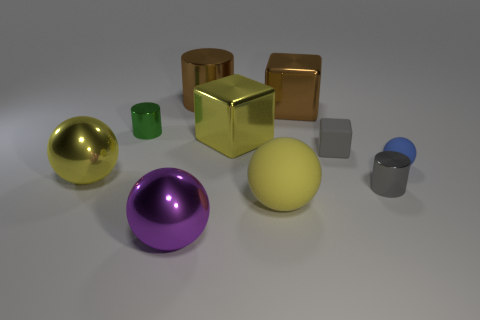There is a object that is behind the tiny matte ball and on the left side of the large purple object; what is its material?
Offer a very short reply. Metal. Is the color of the tiny rubber ball the same as the cylinder on the right side of the small gray rubber block?
Keep it short and to the point. No. There is a purple thing that is the same size as the brown metallic cube; what material is it?
Your answer should be very brief. Metal. Is there a large brown sphere that has the same material as the small gray cube?
Offer a very short reply. No. What number of large purple metal spheres are there?
Provide a short and direct response. 1. Do the big cylinder and the yellow sphere that is in front of the yellow metal ball have the same material?
Offer a very short reply. No. What material is the cylinder that is the same color as the tiny rubber block?
Provide a short and direct response. Metal. How many metal spheres have the same color as the small cube?
Offer a very short reply. 0. The yellow rubber thing is what size?
Provide a succinct answer. Large. Does the tiny blue thing have the same shape as the brown metallic object that is in front of the large shiny cylinder?
Keep it short and to the point. No. 